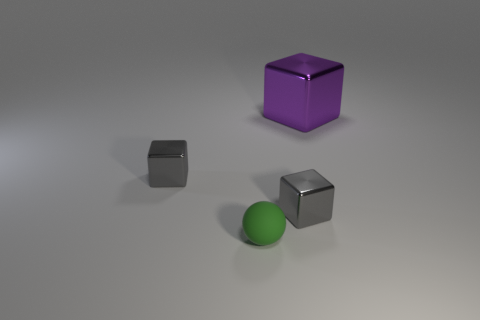Is the number of small metallic objects on the right side of the tiny ball less than the number of gray blocks on the left side of the large purple shiny thing?
Your response must be concise. Yes. Are there any other things that are the same shape as the green rubber object?
Give a very brief answer. No. What material is the gray thing on the right side of the small green matte thing?
Your answer should be compact. Metal. Is there anything else that is the same size as the purple thing?
Provide a short and direct response. No. There is a green ball; are there any small gray metallic objects on the left side of it?
Provide a short and direct response. Yes. What shape is the tiny matte thing?
Provide a succinct answer. Sphere. How many things are objects that are on the left side of the small rubber object or large red metallic balls?
Give a very brief answer. 1. There is a matte sphere; does it have the same color as the tiny metallic object that is to the left of the green matte object?
Your answer should be very brief. No. Are the large cube and the tiny thing that is on the right side of the tiny green sphere made of the same material?
Your answer should be very brief. Yes. What color is the small ball?
Keep it short and to the point. Green. 